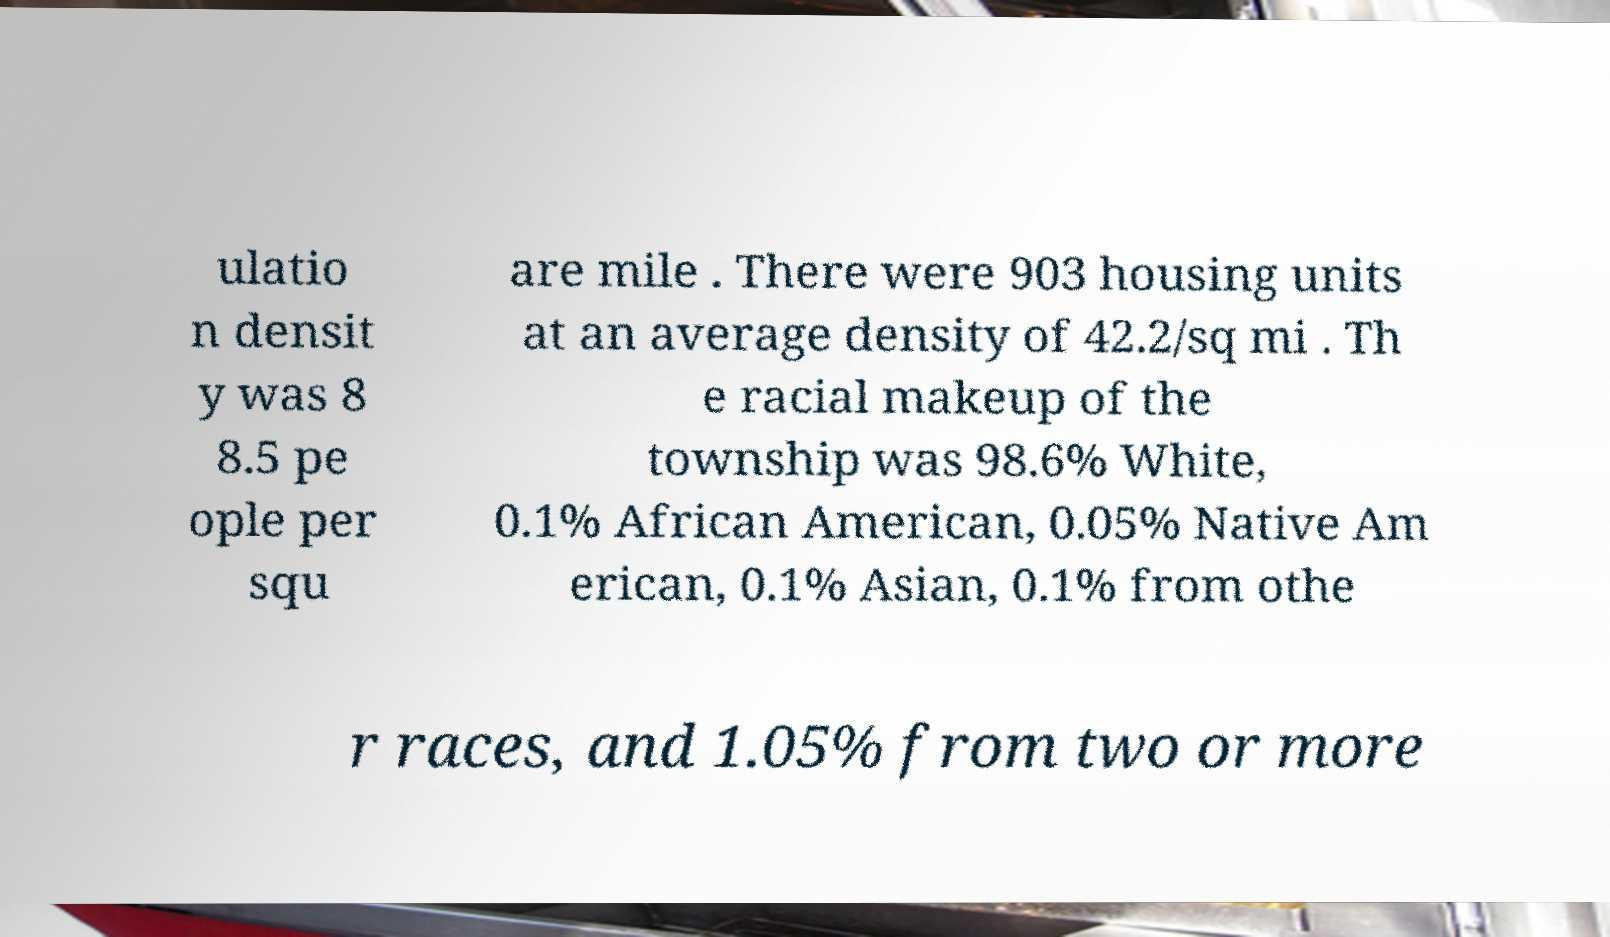Please identify and transcribe the text found in this image. ulatio n densit y was 8 8.5 pe ople per squ are mile . There were 903 housing units at an average density of 42.2/sq mi . Th e racial makeup of the township was 98.6% White, 0.1% African American, 0.05% Native Am erican, 0.1% Asian, 0.1% from othe r races, and 1.05% from two or more 